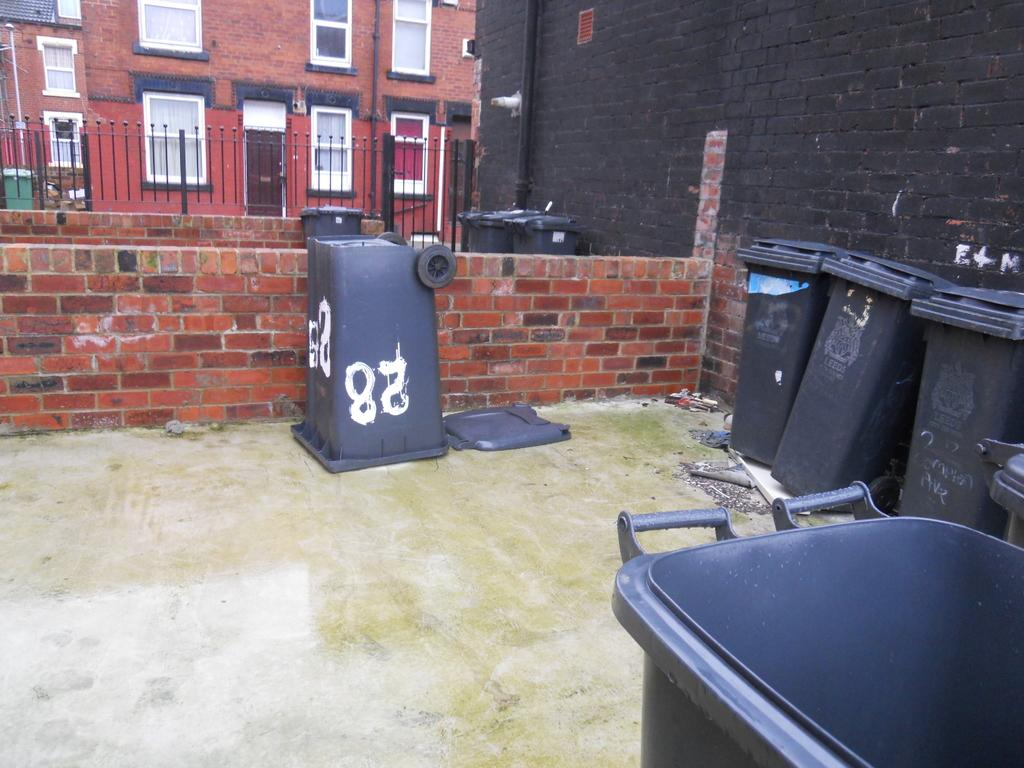<image>
Relay a brief, clear account of the picture shown. A black trash can is upside down, with the number 28 painted on it. 